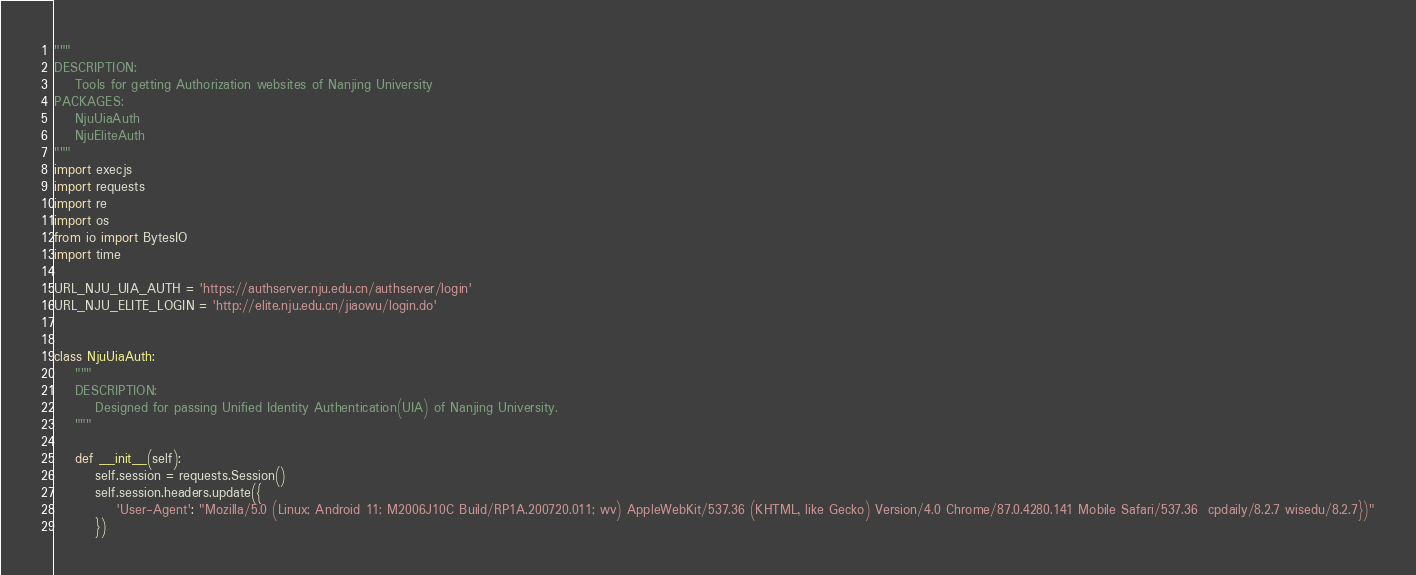<code> <loc_0><loc_0><loc_500><loc_500><_Python_>"""
DESCRIPTION:
    Tools for getting Authorization websites of Nanjing University
PACKAGES:
    NjuUiaAuth
    NjuEliteAuth
"""
import execjs
import requests
import re
import os
from io import BytesIO
import time

URL_NJU_UIA_AUTH = 'https://authserver.nju.edu.cn/authserver/login'
URL_NJU_ELITE_LOGIN = 'http://elite.nju.edu.cn/jiaowu/login.do'


class NjuUiaAuth:
    """
    DESCRIPTION:
        Designed for passing Unified Identity Authentication(UIA) of Nanjing University.
    """

    def __init__(self):
        self.session = requests.Session()
        self.session.headers.update({
            'User-Agent': "Mozilla/5.0 (Linux; Android 11; M2006J10C Build/RP1A.200720.011; wv) AppleWebKit/537.36 (KHTML, like Gecko) Version/4.0 Chrome/87.0.4280.141 Mobile Safari/537.36  cpdaily/8.2.7 wisedu/8.2.7})"
        })
</code> 